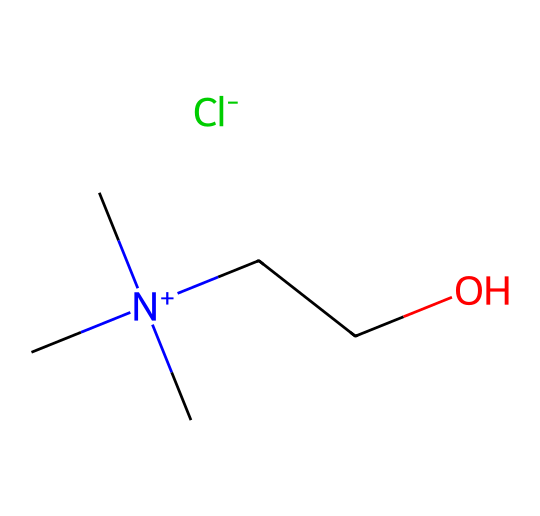what is the total number of atoms in this ionic liquid? To find the total number of atoms, we can break down the SMILES representation. The chemical consists of carbon (C), nitrogen (N), oxygen (O), chlorine (Cl), and their respective counts. Counting the elements: 4 Carbons, 1 Nitrogen, 1 Oxygen, 1 Chlorine, and 12 Hydrogens from the three methyl groups and the ethyl group gives a total of 4 + 1 + 1 + 1 + 12 = 19 atoms.
Answer: 19 how many different elements are present in this ionic liquid? The SMILES indicates the presence of different types of atoms. By identifying each distinct type of atom: Carbon, Nitrogen, Oxygen, and Chlorine, we can see that there are 4 different elements present in the structure.
Answer: 4 what is the formal charge on the nitrogen atom? The nitrogen in the structure is positively charged as indicated by the notation [N+]. This means that it carries a formal charge of +1.
Answer: +1 what role does the chlorine play in this ionic liquid? The chlorine atom, denoted as [Cl-], serves as an anion within the ionic liquid structure. Its negative charge helps to balance the positive charge from the nitrogen atom, making the entire compound neutral.
Answer: anion how does the structure of this ionic liquid affect its viscosity at different temperatures? The presence of long alkyl chains and the bulky quaternary ammonium structure typically lowers the viscosity of ionic liquids compared to conventional salts. Additionally, temperature increases generally reduce viscosity as the molecular motion increases, which is significant in applications like inks.
Answer: lowers viscosity what type of ionic liquid is represented by this SMILES? This ionic liquid belongs to the category of ammonium ionic liquids, characterized by quaternary ammonium cations, specifically due to the presence of the [N+] substituent.
Answer: ammonium ionic liquid describe the overall charge of the compound represented by the SMILES. In the given SMILES structure, the nitrogen is positively charged while the chlorine is negatively charged. The overall charge is neutral since these charges balance each other out.
Answer: neutral 